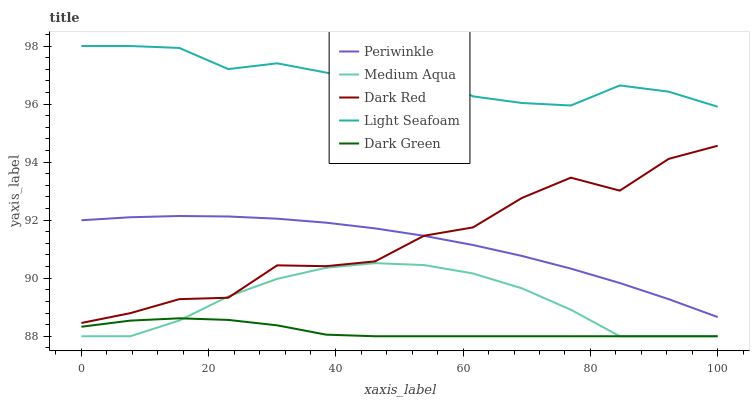Does Dark Green have the minimum area under the curve?
Answer yes or no. Yes. Does Light Seafoam have the maximum area under the curve?
Answer yes or no. Yes. Does Periwinkle have the minimum area under the curve?
Answer yes or no. No. Does Periwinkle have the maximum area under the curve?
Answer yes or no. No. Is Periwinkle the smoothest?
Answer yes or no. Yes. Is Dark Red the roughest?
Answer yes or no. Yes. Is Light Seafoam the smoothest?
Answer yes or no. No. Is Light Seafoam the roughest?
Answer yes or no. No. Does Medium Aqua have the lowest value?
Answer yes or no. Yes. Does Periwinkle have the lowest value?
Answer yes or no. No. Does Light Seafoam have the highest value?
Answer yes or no. Yes. Does Periwinkle have the highest value?
Answer yes or no. No. Is Dark Red less than Light Seafoam?
Answer yes or no. Yes. Is Periwinkle greater than Medium Aqua?
Answer yes or no. Yes. Does Medium Aqua intersect Dark Green?
Answer yes or no. Yes. Is Medium Aqua less than Dark Green?
Answer yes or no. No. Is Medium Aqua greater than Dark Green?
Answer yes or no. No. Does Dark Red intersect Light Seafoam?
Answer yes or no. No. 